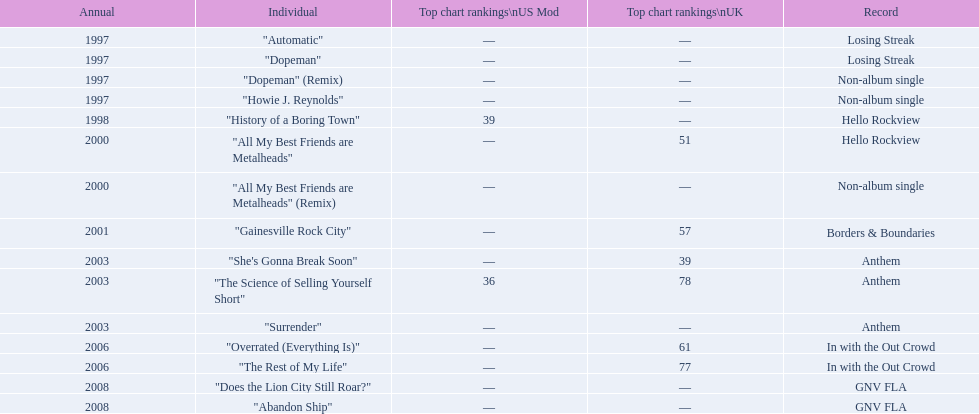What was the first single to earn a chart position? "History of a Boring Town". 